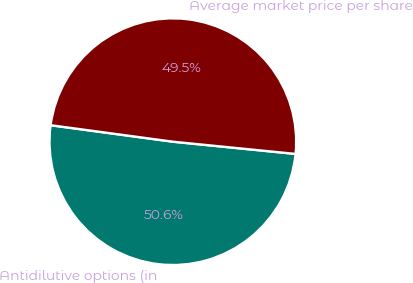<chart> <loc_0><loc_0><loc_500><loc_500><pie_chart><fcel>Antidilutive options (in<fcel>Average market price per share<nl><fcel>50.55%<fcel>49.45%<nl></chart> 